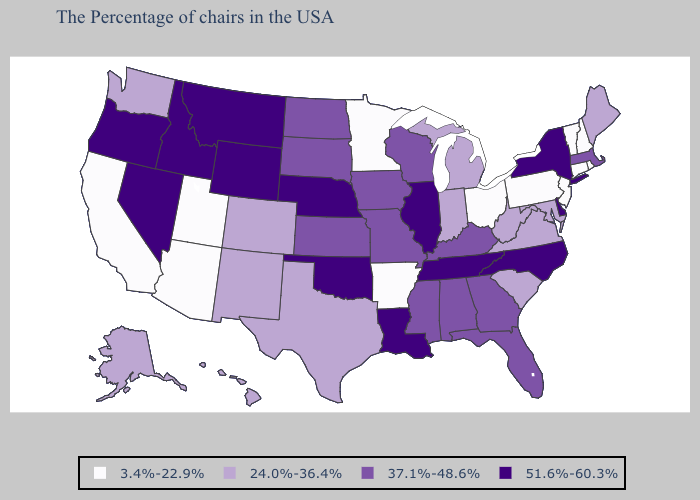Does Ohio have the same value as Minnesota?
Be succinct. Yes. What is the lowest value in states that border North Dakota?
Write a very short answer. 3.4%-22.9%. What is the highest value in the MidWest ?
Answer briefly. 51.6%-60.3%. Name the states that have a value in the range 51.6%-60.3%?
Short answer required. New York, Delaware, North Carolina, Tennessee, Illinois, Louisiana, Nebraska, Oklahoma, Wyoming, Montana, Idaho, Nevada, Oregon. Does Texas have the same value as Virginia?
Answer briefly. Yes. Does the map have missing data?
Give a very brief answer. No. What is the value of Wyoming?
Answer briefly. 51.6%-60.3%. Does Connecticut have the same value as Pennsylvania?
Write a very short answer. Yes. Name the states that have a value in the range 37.1%-48.6%?
Write a very short answer. Massachusetts, Florida, Georgia, Kentucky, Alabama, Wisconsin, Mississippi, Missouri, Iowa, Kansas, South Dakota, North Dakota. Which states have the highest value in the USA?
Be succinct. New York, Delaware, North Carolina, Tennessee, Illinois, Louisiana, Nebraska, Oklahoma, Wyoming, Montana, Idaho, Nevada, Oregon. What is the highest value in the MidWest ?
Answer briefly. 51.6%-60.3%. What is the value of Nevada?
Give a very brief answer. 51.6%-60.3%. Name the states that have a value in the range 24.0%-36.4%?
Write a very short answer. Maine, Maryland, Virginia, South Carolina, West Virginia, Michigan, Indiana, Texas, Colorado, New Mexico, Washington, Alaska, Hawaii. Name the states that have a value in the range 37.1%-48.6%?
Answer briefly. Massachusetts, Florida, Georgia, Kentucky, Alabama, Wisconsin, Mississippi, Missouri, Iowa, Kansas, South Dakota, North Dakota. Name the states that have a value in the range 3.4%-22.9%?
Short answer required. Rhode Island, New Hampshire, Vermont, Connecticut, New Jersey, Pennsylvania, Ohio, Arkansas, Minnesota, Utah, Arizona, California. 